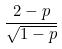Convert formula to latex. <formula><loc_0><loc_0><loc_500><loc_500>\frac { 2 - p } { \sqrt { 1 - p } }</formula> 